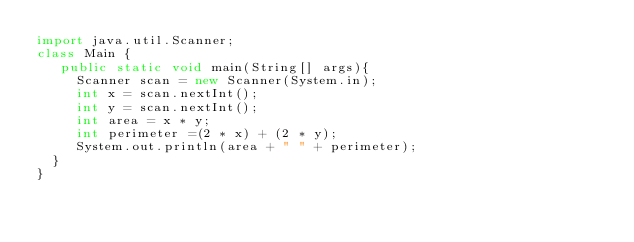Convert code to text. <code><loc_0><loc_0><loc_500><loc_500><_Java_>import java.util.Scanner; 
class Main {
   public static void main(String[] args){
     Scanner scan = new Scanner(System.in);
     int x = scan.nextInt();
     int y = scan.nextInt();
     int area = x * y;
     int perimeter =(2 * x) + (2 * y);
     System.out.println(area + " " + perimeter);
  }
}
</code> 